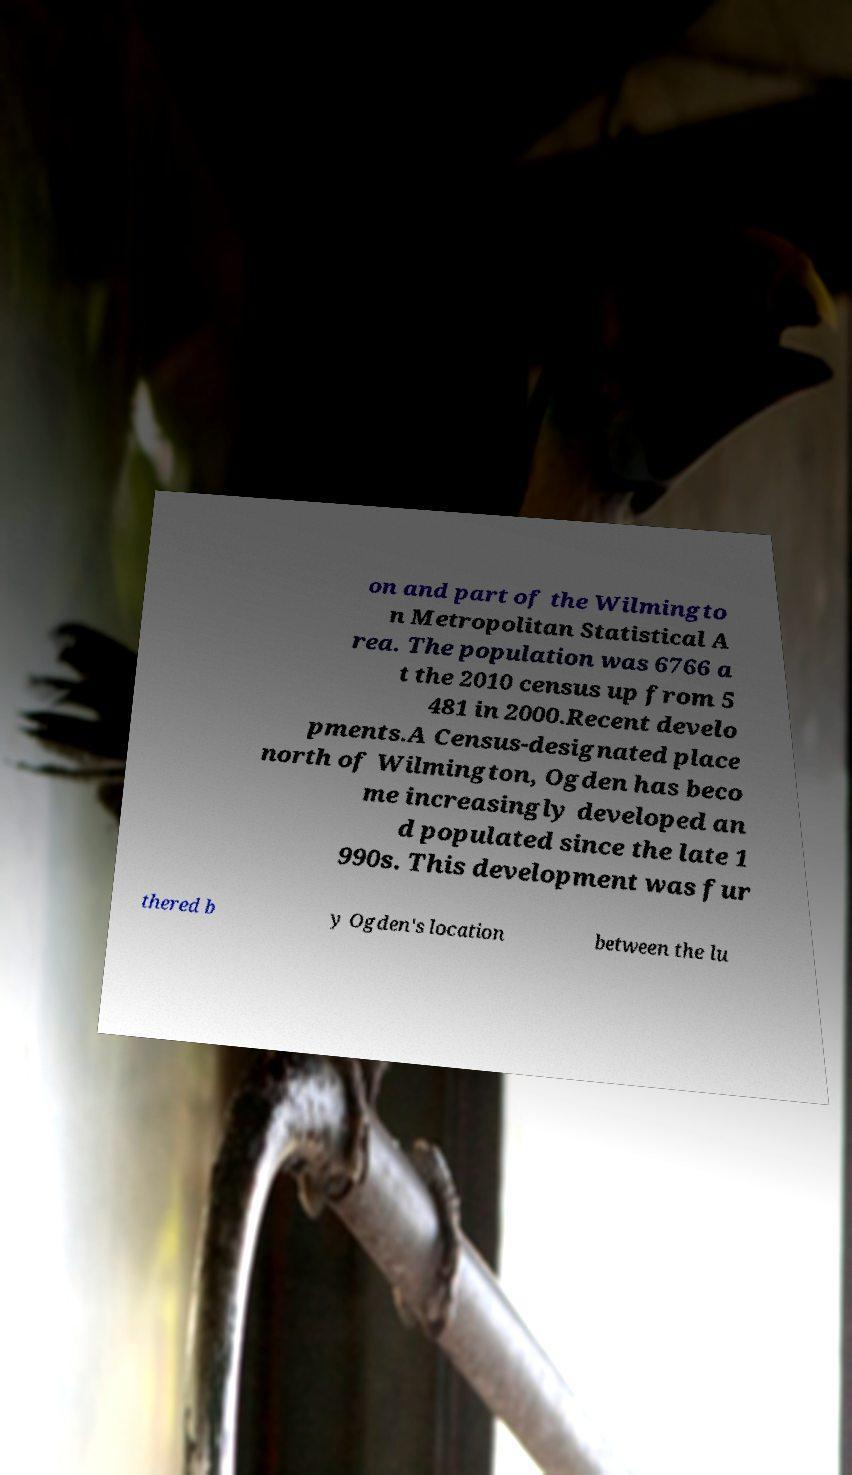Could you extract and type out the text from this image? on and part of the Wilmingto n Metropolitan Statistical A rea. The population was 6766 a t the 2010 census up from 5 481 in 2000.Recent develo pments.A Census-designated place north of Wilmington, Ogden has beco me increasingly developed an d populated since the late 1 990s. This development was fur thered b y Ogden's location between the lu 